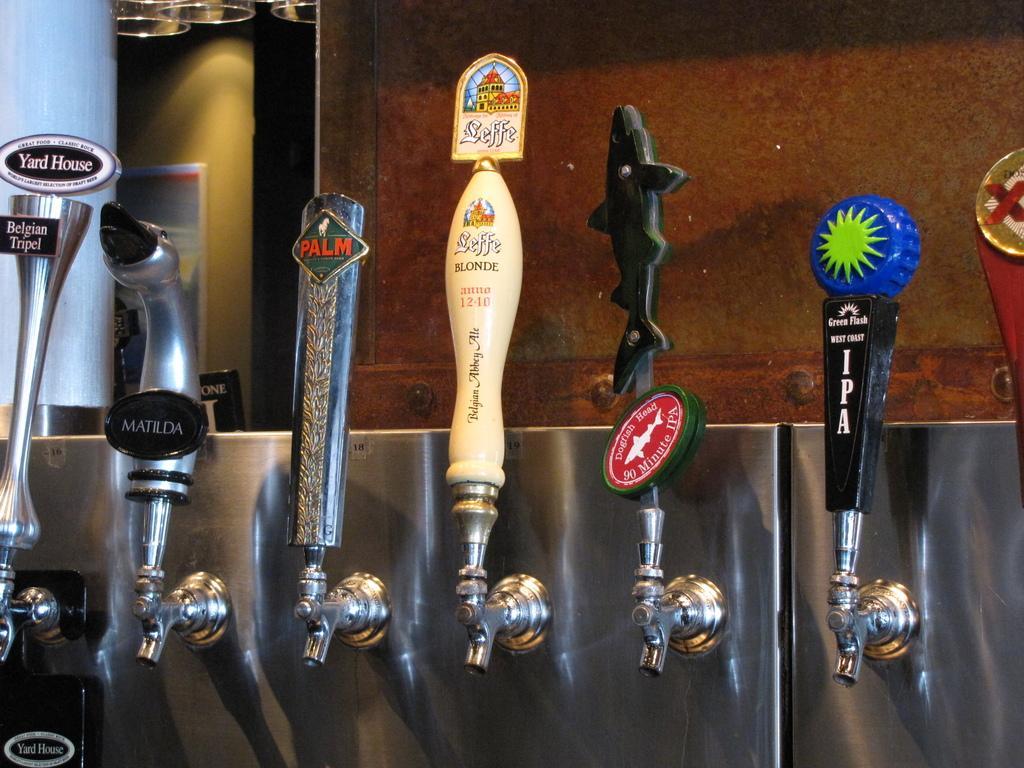Can you describe this image briefly? In this picture we can observe different types of taps. We can observe black, blue, red and cream color taps. In the background there is brown color wall. 